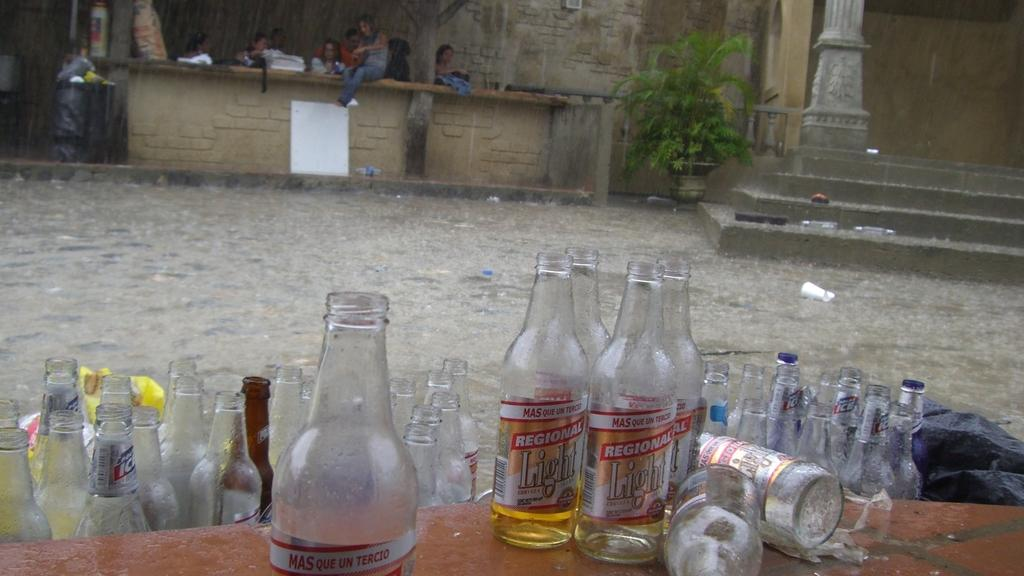<image>
Create a compact narrative representing the image presented. Many bottles of Regional Light beer outdoors on a table. 